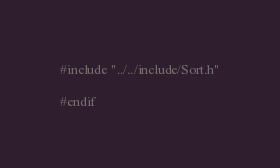Convert code to text. <code><loc_0><loc_0><loc_500><loc_500><_C_>#include "../../include/Sort.h"

#endif</code> 